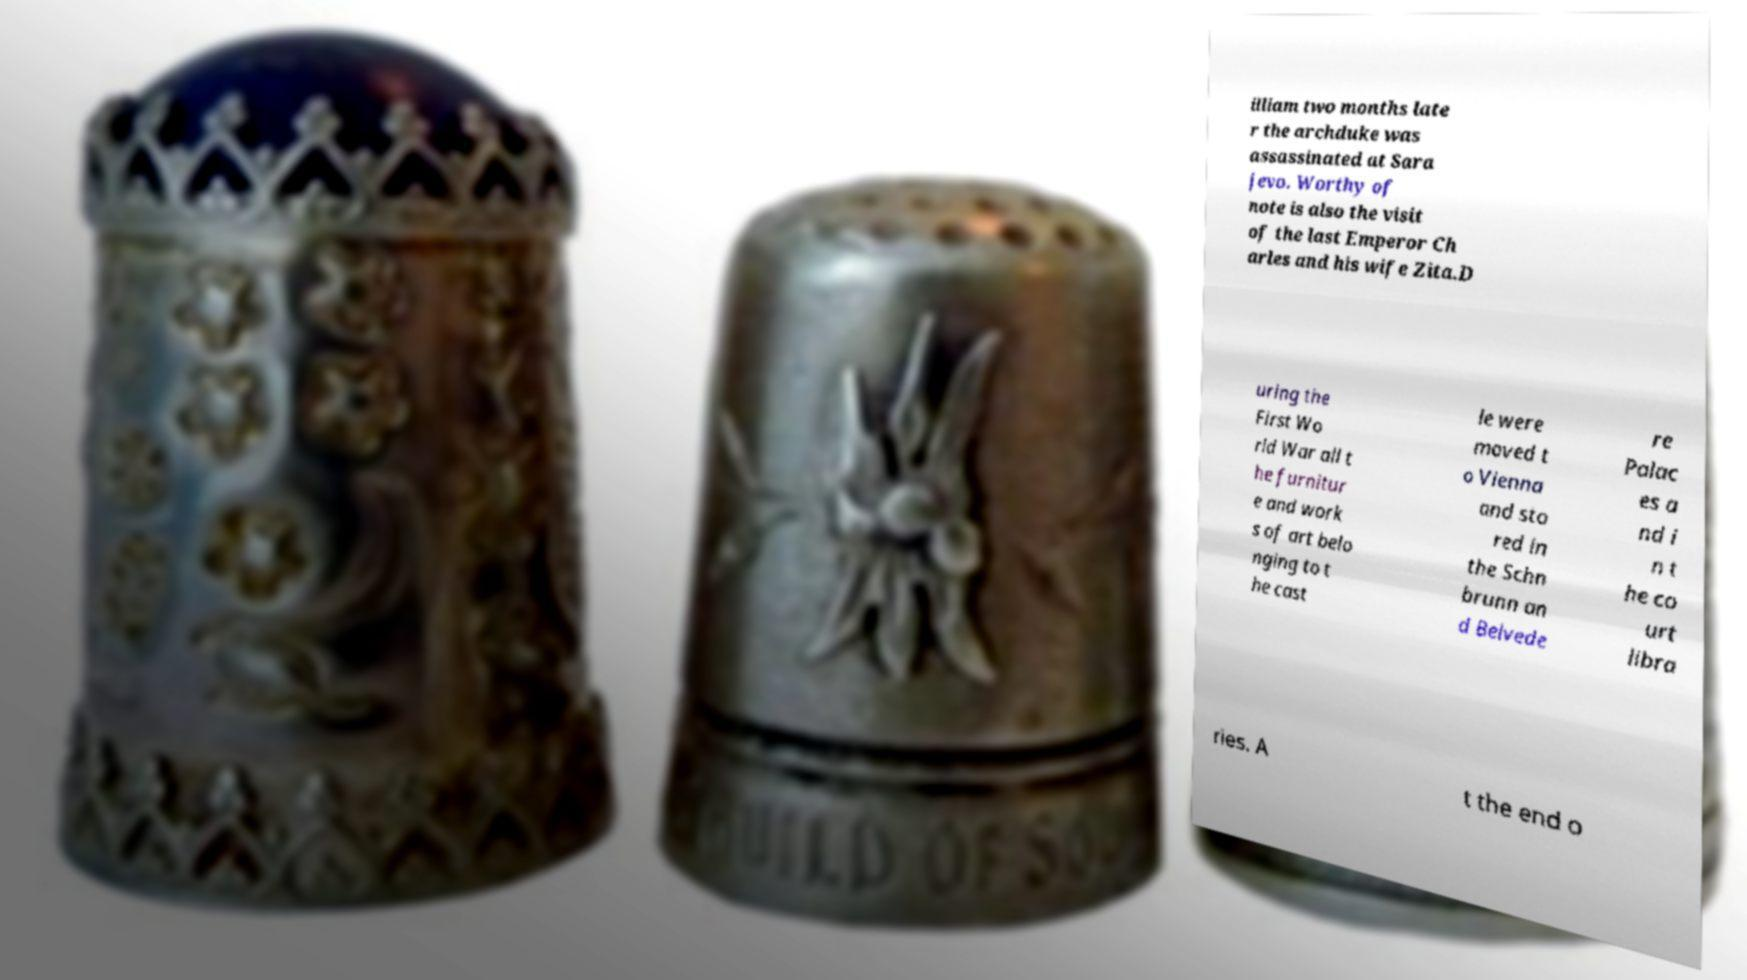What messages or text are displayed in this image? I need them in a readable, typed format. illiam two months late r the archduke was assassinated at Sara jevo. Worthy of note is also the visit of the last Emperor Ch arles and his wife Zita.D uring the First Wo rld War all t he furnitur e and work s of art belo nging to t he cast le were moved t o Vienna and sto red in the Schn brunn an d Belvede re Palac es a nd i n t he co urt libra ries. A t the end o 